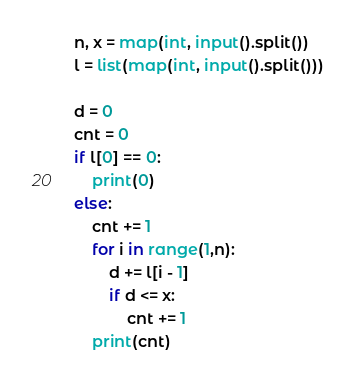Convert code to text. <code><loc_0><loc_0><loc_500><loc_500><_Python_>n, x = map(int, input().split())
l = list(map(int, input().split()))

d = 0
cnt = 0
if l[0] == 0:
    print(0)
else:
    cnt += 1
    for i in range(1,n):
        d += l[i - 1]
        if d <= x:
            cnt += 1
    print(cnt)
</code> 